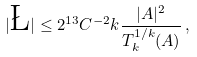Convert formula to latex. <formula><loc_0><loc_0><loc_500><loc_500>| \L | \leq 2 ^ { 1 3 } C ^ { - 2 } k \frac { | A | ^ { 2 } } { T ^ { 1 / k } _ { k } ( A ) } \, ,</formula> 